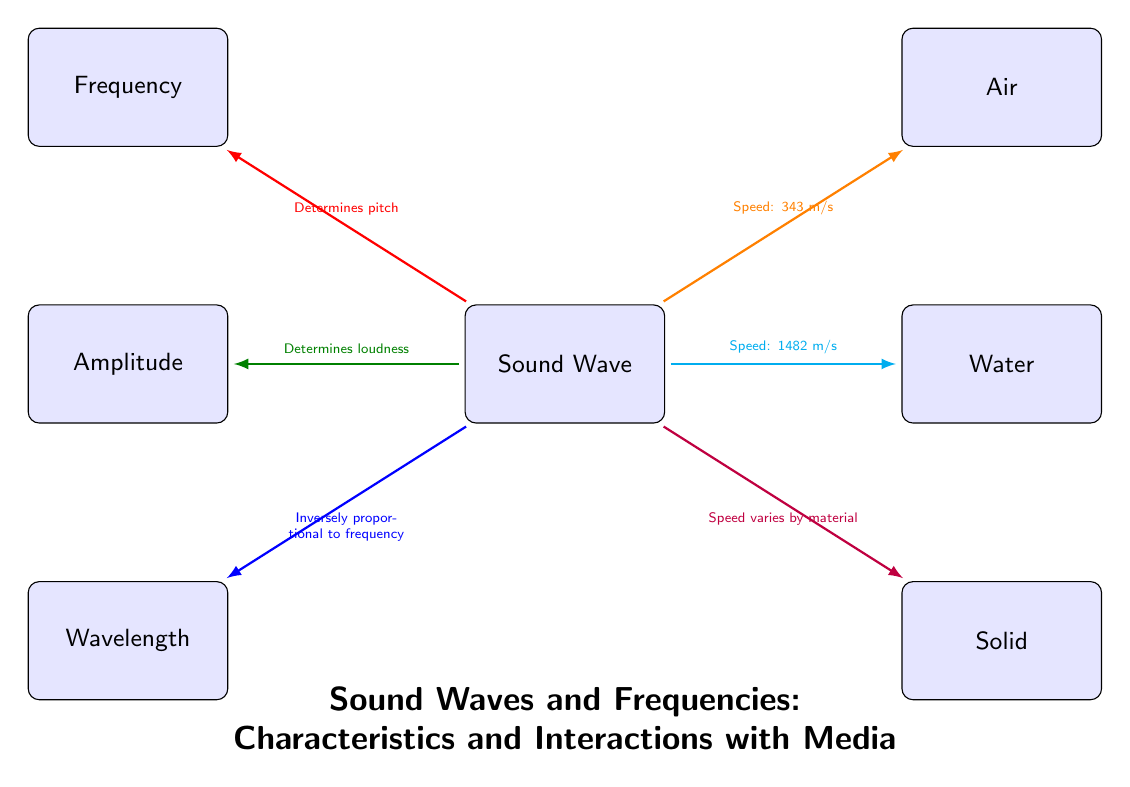What determines the pitch of a sound wave? The diagram indicates that the frequency is the factor that determines pitch, as shown by the red arrow connecting the sound wave to the frequency node.
Answer: Frequency What is the loudness of sound waves determined by? The green arrow in the diagram connects the sound wave to the amplitude, indicating that amplitude determines the loudness of sound waves.
Answer: Amplitude What is the speed of sound in air? As noted in the diagram with an orange arrow, the speed of sound in air is specified as 343 m/s.
Answer: 343 m/s Which medium has the highest speed of sound according to the diagram? By comparing the values shown in the diagram, the speed of sound in water (1482 m/s) is identified as being faster than in air (343 m/s) and implies that solids generally have a higher speed, therefore solid is the answer here as it states "Speed varies by material."
Answer: Solid What is the relationship between wavelength and frequency in sound waves? The diagram illustrates that wavelength is inversely proportional to frequency, indicated by the blue line connecting the sound wave to the wavelength node. This relationship suggests that as frequency increases, wavelength decreases.
Answer: Inversely proportional to frequency How many types of media are shown in the diagram? The diagram displays three media types: air, water, and solid, indicated by the connections from the sound wave. Counting these provides the answer.
Answer: Three Which characteristic of sound is associated with the color green in the diagram? The color green in the diagram is associated with the amplitude, which connects to the sound wave and indicates its role in determining loudness.
Answer: Loudness What does the wavelength indicate in relation to sound waves? The diagram notes that wavelength is inversely proportional to frequency, suggesting that the wavelength indicates the relationship with the speed of sound; longer wavelengths correspond with lower frequencies.
Answer: Inversely proportional to frequency 